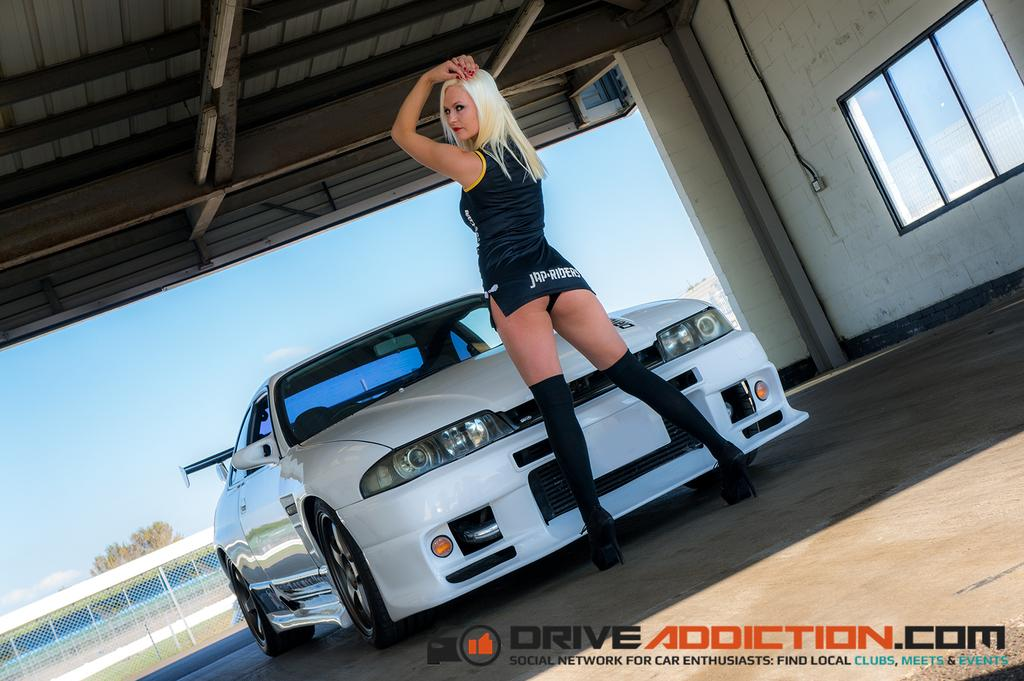Who is the main subject in the image? There is a girl in the image. What is the girl standing in front of? The girl is standing in front of a white car. Is there any text visible in the image? Yes, there is text written on the right bottom side of the image. How many rings can be seen on the girl's fingers in the image? There are no rings visible on the girl's fingers in the image. Is there a swing present in the image? No, there is no swing present in the image. 